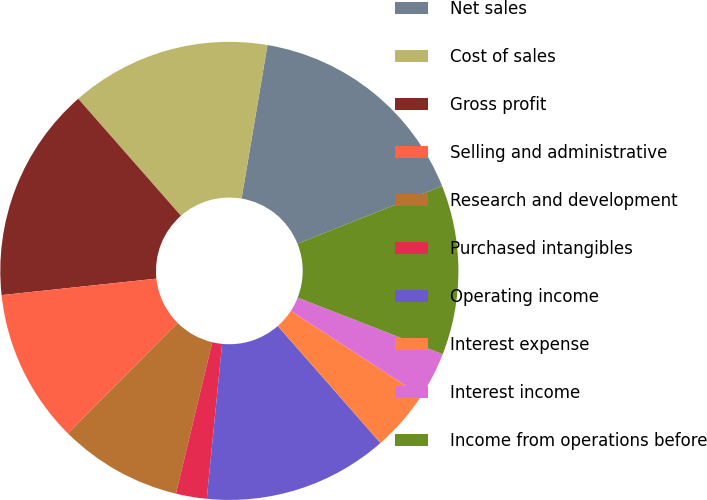Convert chart to OTSL. <chart><loc_0><loc_0><loc_500><loc_500><pie_chart><fcel>Net sales<fcel>Cost of sales<fcel>Gross profit<fcel>Selling and administrative<fcel>Research and development<fcel>Purchased intangibles<fcel>Operating income<fcel>Interest expense<fcel>Interest income<fcel>Income from operations before<nl><fcel>16.3%<fcel>14.13%<fcel>15.22%<fcel>10.87%<fcel>8.7%<fcel>2.17%<fcel>13.04%<fcel>4.35%<fcel>3.26%<fcel>11.96%<nl></chart> 